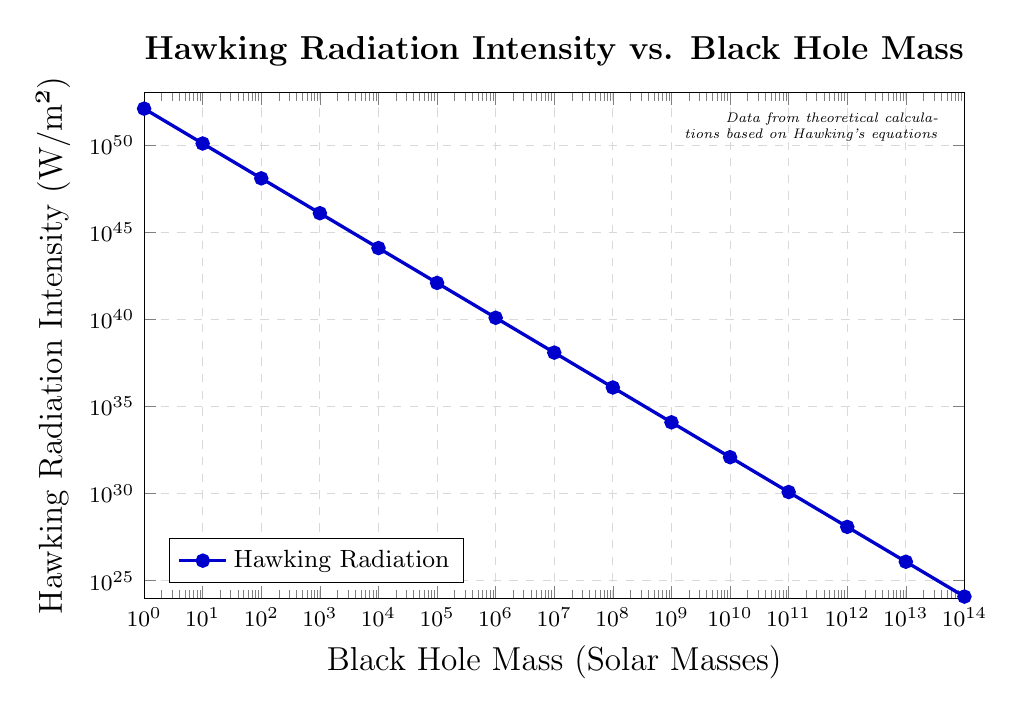What is the relationship between black hole mass and Hawking radiation intensity? I can see from the figure that as the black hole mass increases, the Hawking radiation intensity decreases. This indicates an inverse relationship, where larger black holes emit less radiation per unit area.
Answer: Inverse relationship What is the Hawking radiation intensity for a black hole with a mass of 1000 solar masses? The figure shows that for a black hole with a mass of 1000 solar masses, the corresponding Hawking radiation intensity is marked at 1.23e46 W/m².
Answer: 1.23e46 W/m² By what factor does the Hawking radiation intensity decrease when the black hole mass increases from 10 solar masses to 100 solar masses? The radiation intensity for 10 solar masses is 1.23e50 W/m² and for 100 solar masses is 1.23e48 W/m². Dividing the former by the latter gives \( \frac{1.23e50}{1.23e48} = 100 \), a factor decrease of 100.
Answer: 100 Which has a higher Hawking radiation intensity: a black hole with 1 solar mass or with 1,000,000 solar masses, and by how much? The radiation intensity for 1 solar mass is 1.23e52 W/m², and for 1,000,000 solar masses is 1.23e40 W/m². To find out how much higher the former is, divide 1.23e52 by 1.23e40, resulting in a factor difference of \( 1e12 \).
Answer: 1 is higher by a factor of 1e12 What is the general visual trend of the data plotted in the figure? From the log-log plot, it is visible that the line connecting data points slopes downward consistently from left to right, indicating a monotonically decreasing trend of Hawking radiation intensity as black hole mass increases.
Answer: Monotonically decreasing If we average the Hawking radiation intensity values for black holes with masses of 10 and 1000 solar masses, what is the resulting value? The radiation intensity values are 1.23e50 for 10 solar masses and 1.23e46 for 1000 solar masses. To find the average, sum these values and divide by 2: \( \frac{1.23e50 + 1.23e46}{2} \approx 6.15e49 \).
Answer: 6.15e49 W/m² What is the steepest segment of the curve on the plot? The steepest segment of the curve appears where there is the highest rate of decrease in Hawking radiation intensity per unit increase in black hole mass. Examining the plot, the segment between 1 and 10 solar masses shows a marked steep decline.
Answer: Between 1 and 10 solar masses Which black hole mass results in the lowest observed Hawking radiation intensity, and what is that intensity? The lowest observed Hawking radiation intensity corresponds to the highest black hole mass on the plot, which is 1e14 solar masses. The intensity at this point is shown as 1.23e24 W/m².
Answer: 1e14 solar masses, 1.23e24 W/m² How does the visual grid style help in understanding the plot? The grid lines, being dashed and styled in gray, create a clear reference framework without overshadowing the data points and lines, aiding in precise value extraction and enhancing readability across the logarithmic axes.
Answer: Enhanced readability and precision Summarize the unit on the logarithmic y-axis and the range of values it covers. The y-axis represents Hawking radiation intensity in W/m², covering a range from 1e24 to 1e53.
Answer: W/m², 1e24 to 1e53 